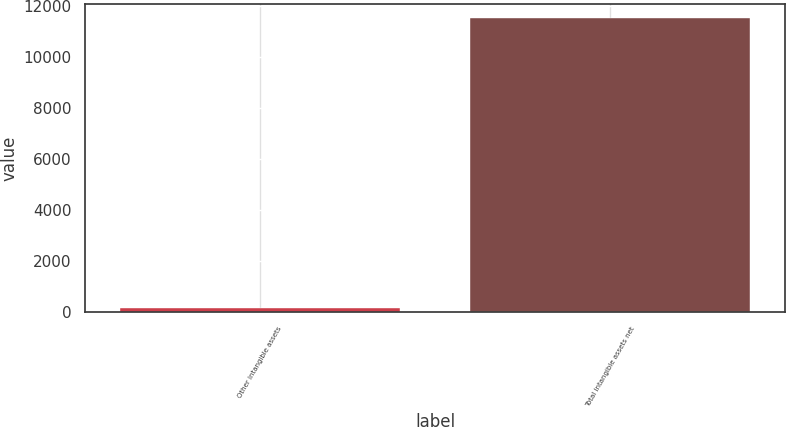Convert chart to OTSL. <chart><loc_0><loc_0><loc_500><loc_500><bar_chart><fcel>Other intangible assets<fcel>Total intangible assets net<nl><fcel>148<fcel>11522<nl></chart> 